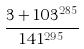Convert formula to latex. <formula><loc_0><loc_0><loc_500><loc_500>\frac { 3 + 1 0 3 ^ { 2 8 5 } } { 1 4 1 ^ { 2 9 5 } }</formula> 